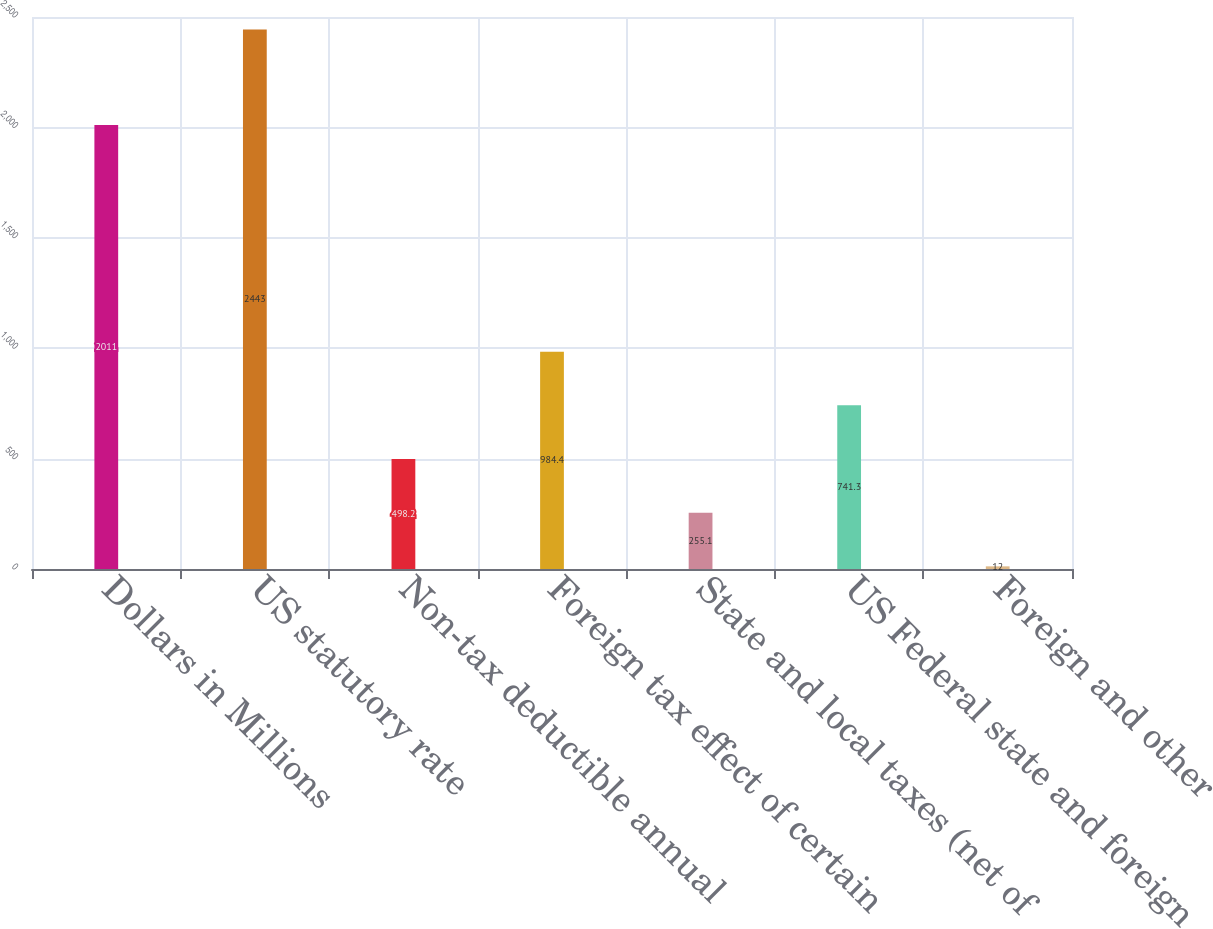Convert chart to OTSL. <chart><loc_0><loc_0><loc_500><loc_500><bar_chart><fcel>Dollars in Millions<fcel>US statutory rate<fcel>Non-tax deductible annual<fcel>Foreign tax effect of certain<fcel>State and local taxes (net of<fcel>US Federal state and foreign<fcel>Foreign and other<nl><fcel>2011<fcel>2443<fcel>498.2<fcel>984.4<fcel>255.1<fcel>741.3<fcel>12<nl></chart> 